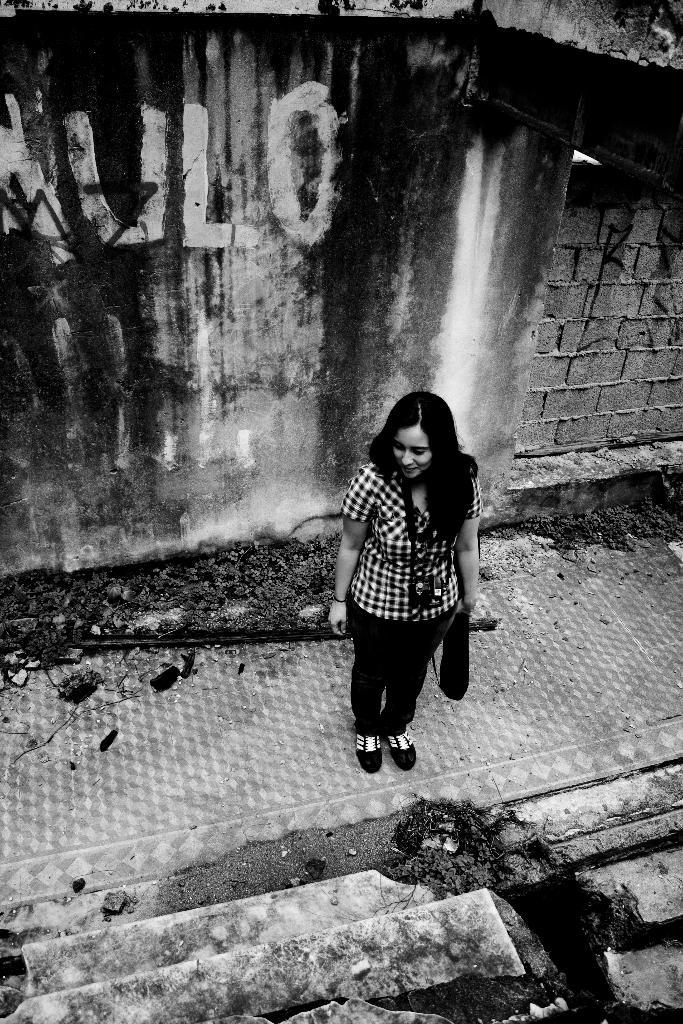What is the color scheme of the image? The image is black and white. Who or what is the main subject in the image? There is a woman in the image. What is the woman doing in the image? The woman is standing on a surface. What can be seen behind the woman in the image? There is a wall behind the woman. Can you see a gun hanging on the wall behind the woman in the image? There is no gun present in the image; it is a black and white image of a woman standing on a surface with a wall behind her. 